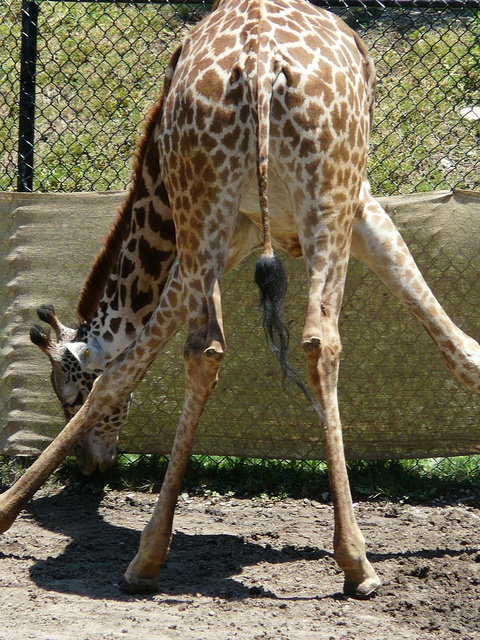Describe the objects in this image and their specific colors. I can see a giraffe in olive, black, gray, and maroon tones in this image. 